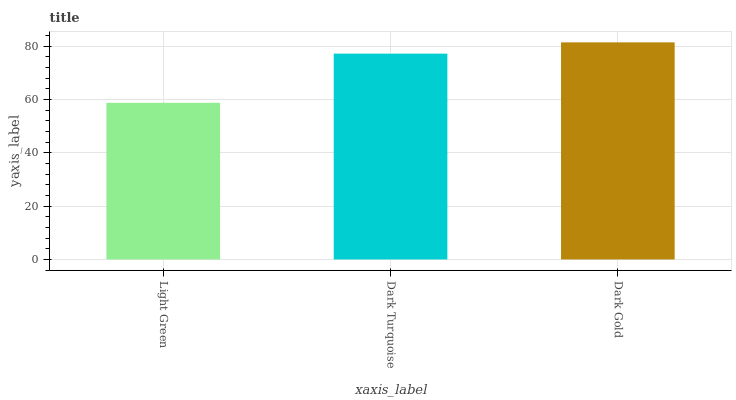Is Light Green the minimum?
Answer yes or no. Yes. Is Dark Gold the maximum?
Answer yes or no. Yes. Is Dark Turquoise the minimum?
Answer yes or no. No. Is Dark Turquoise the maximum?
Answer yes or no. No. Is Dark Turquoise greater than Light Green?
Answer yes or no. Yes. Is Light Green less than Dark Turquoise?
Answer yes or no. Yes. Is Light Green greater than Dark Turquoise?
Answer yes or no. No. Is Dark Turquoise less than Light Green?
Answer yes or no. No. Is Dark Turquoise the high median?
Answer yes or no. Yes. Is Dark Turquoise the low median?
Answer yes or no. Yes. Is Dark Gold the high median?
Answer yes or no. No. Is Light Green the low median?
Answer yes or no. No. 